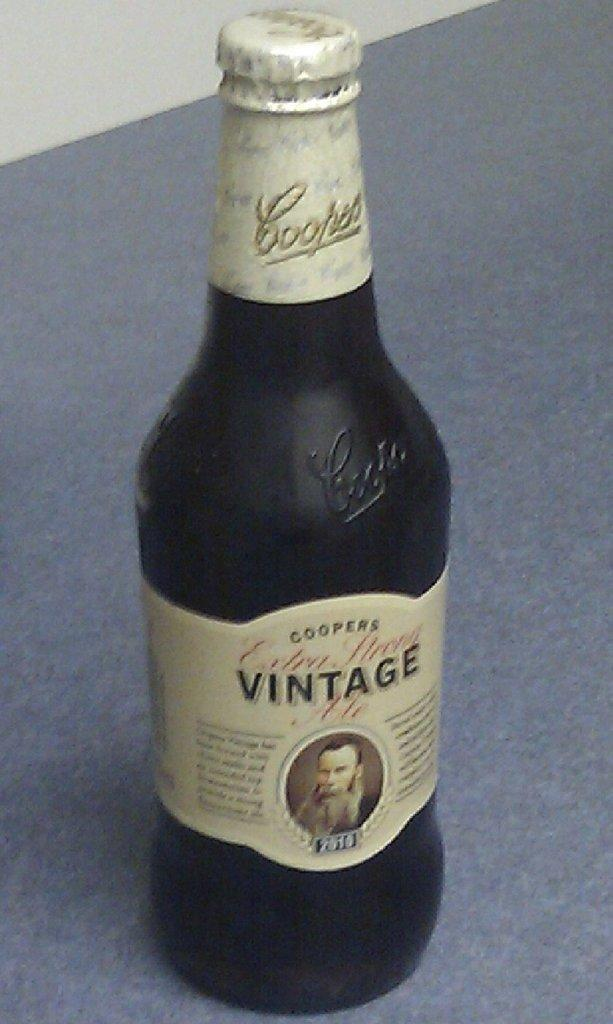<image>
Present a compact description of the photo's key features. A black bottle of vintage ale with a gold label. 